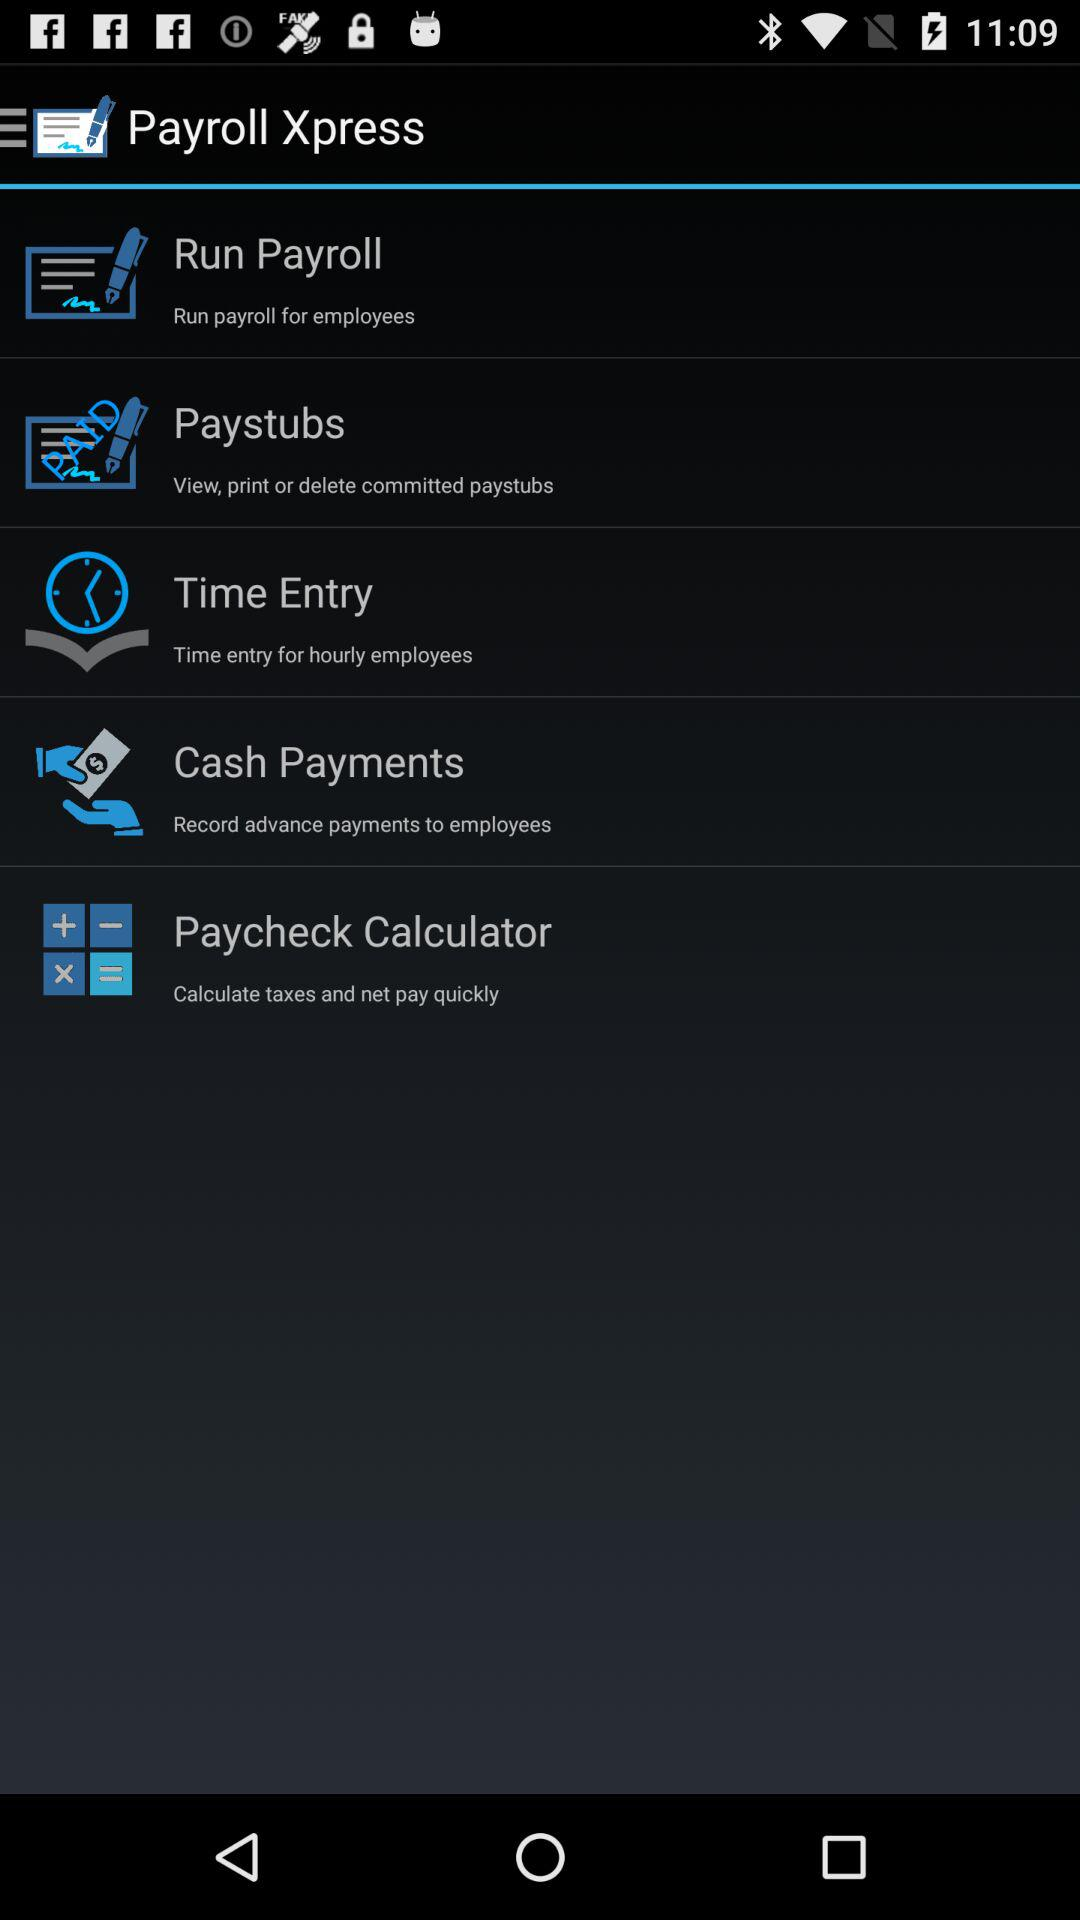Name the option which is paid?
When the provided information is insufficient, respond with <no answer>. <no answer> 